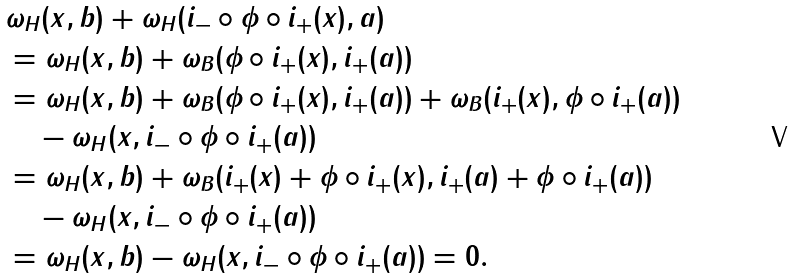<formula> <loc_0><loc_0><loc_500><loc_500>& \omega _ { H } ( x , b ) + \omega _ { H } ( { i } _ { - } \circ \phi \circ { i } _ { + } ( x ) , a ) \\ & = \omega _ { H } ( x , b ) + \omega _ { B } ( \phi \circ { i } _ { + } ( x ) , { i } _ { + } ( a ) ) \\ & = \omega _ { H } ( x , b ) + \omega _ { B } ( \phi \circ { i } _ { + } ( x ) , { i } _ { + } ( a ) ) + \omega _ { B } ( { i } _ { + } ( x ) , \phi \circ { i } _ { + } ( a ) ) \\ & \quad - \omega _ { H } ( x , { i } _ { - } \circ \phi \circ { i } _ { + } ( a ) ) \\ & = \omega _ { H } ( x , b ) + \omega _ { B } ( { i } _ { + } ( x ) + \phi \circ { i } _ { + } ( x ) , { i } _ { + } ( a ) + \phi \circ { i } _ { + } ( a ) ) \\ & \quad - \omega _ { H } ( x , { i } _ { - } \circ \phi \circ { i } _ { + } ( a ) ) \\ & = \omega _ { H } ( x , b ) - \omega _ { H } ( x , { i } _ { - } \circ \phi \circ { i } _ { + } ( a ) ) = 0 .</formula> 